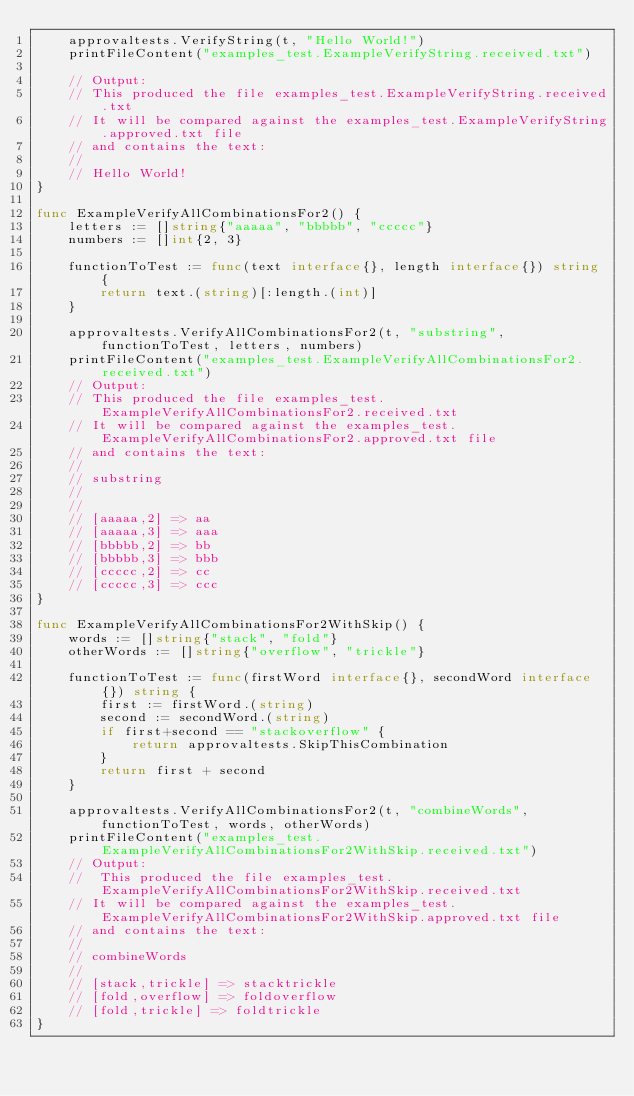<code> <loc_0><loc_0><loc_500><loc_500><_Go_>	approvaltests.VerifyString(t, "Hello World!")
	printFileContent("examples_test.ExampleVerifyString.received.txt")

	// Output:
	// This produced the file examples_test.ExampleVerifyString.received.txt
	// It will be compared against the examples_test.ExampleVerifyString.approved.txt file
	// and contains the text:
	//
	// Hello World!
}

func ExampleVerifyAllCombinationsFor2() {
	letters := []string{"aaaaa", "bbbbb", "ccccc"}
	numbers := []int{2, 3}

	functionToTest := func(text interface{}, length interface{}) string {
		return text.(string)[:length.(int)]
	}

	approvaltests.VerifyAllCombinationsFor2(t, "substring", functionToTest, letters, numbers)
	printFileContent("examples_test.ExampleVerifyAllCombinationsFor2.received.txt")
	// Output:
	// This produced the file examples_test.ExampleVerifyAllCombinationsFor2.received.txt
	// It will be compared against the examples_test.ExampleVerifyAllCombinationsFor2.approved.txt file
	// and contains the text:
	//
	// substring
	//
	//
	// [aaaaa,2] => aa
	// [aaaaa,3] => aaa
	// [bbbbb,2] => bb
	// [bbbbb,3] => bbb
	// [ccccc,2] => cc
	// [ccccc,3] => ccc
}

func ExampleVerifyAllCombinationsFor2WithSkip() {
	words := []string{"stack", "fold"}
	otherWords := []string{"overflow", "trickle"}

	functionToTest := func(firstWord interface{}, secondWord interface{}) string {
		first := firstWord.(string)
		second := secondWord.(string)
		if first+second == "stackoverflow" {
			return approvaltests.SkipThisCombination
		}
		return first + second
	}

	approvaltests.VerifyAllCombinationsFor2(t, "combineWords", functionToTest, words, otherWords)
	printFileContent("examples_test.ExampleVerifyAllCombinationsFor2WithSkip.received.txt")
	// Output:
	// 	This produced the file examples_test.ExampleVerifyAllCombinationsFor2WithSkip.received.txt
	// It will be compared against the examples_test.ExampleVerifyAllCombinationsFor2WithSkip.approved.txt file
	// and contains the text:
	//
	// combineWords
	//
	// [stack,trickle] => stacktrickle
	// [fold,overflow] => foldoverflow
	// [fold,trickle] => foldtrickle
}
</code> 